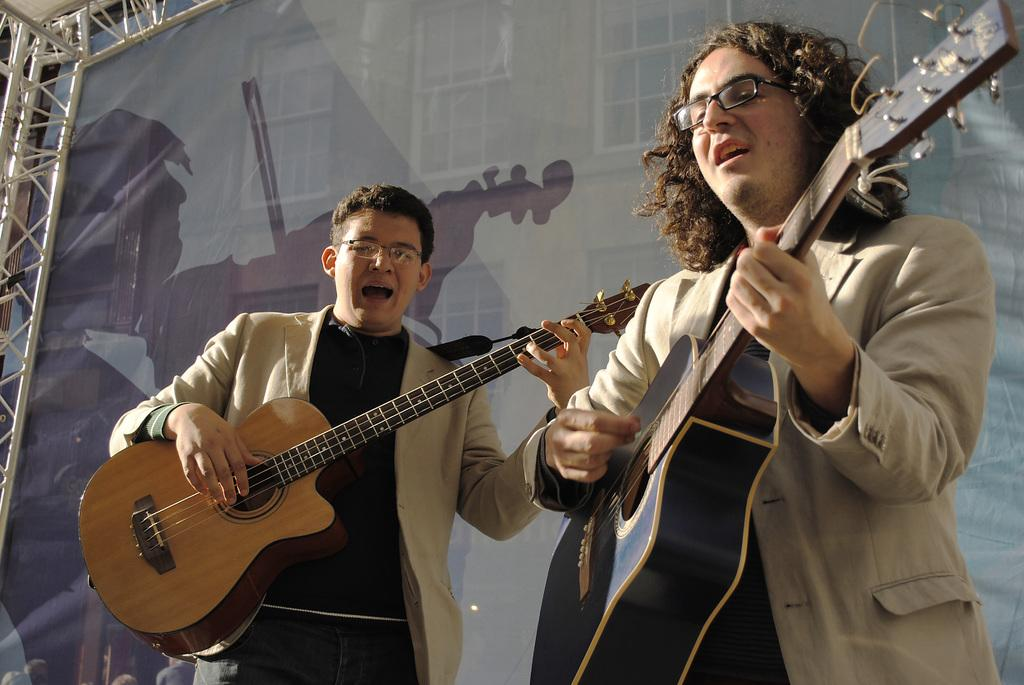How many people are in the image? There are two persons in the image. What are the two persons doing in the image? The two persons are holding a guitar and singing. What type of nail can be seen in the image? There is no nail present in the image. What type of ray is visible in the image? There is no ray present in the image. 